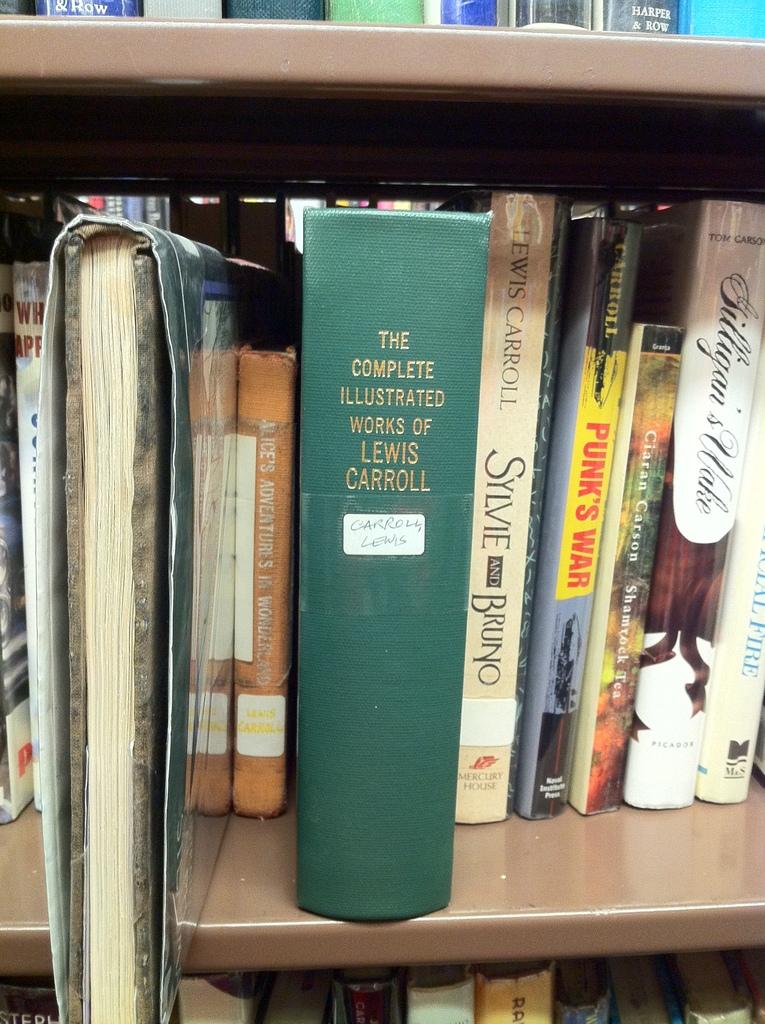Who wrote sylvie and bruno?
Your answer should be very brief. Lewis carroll. 